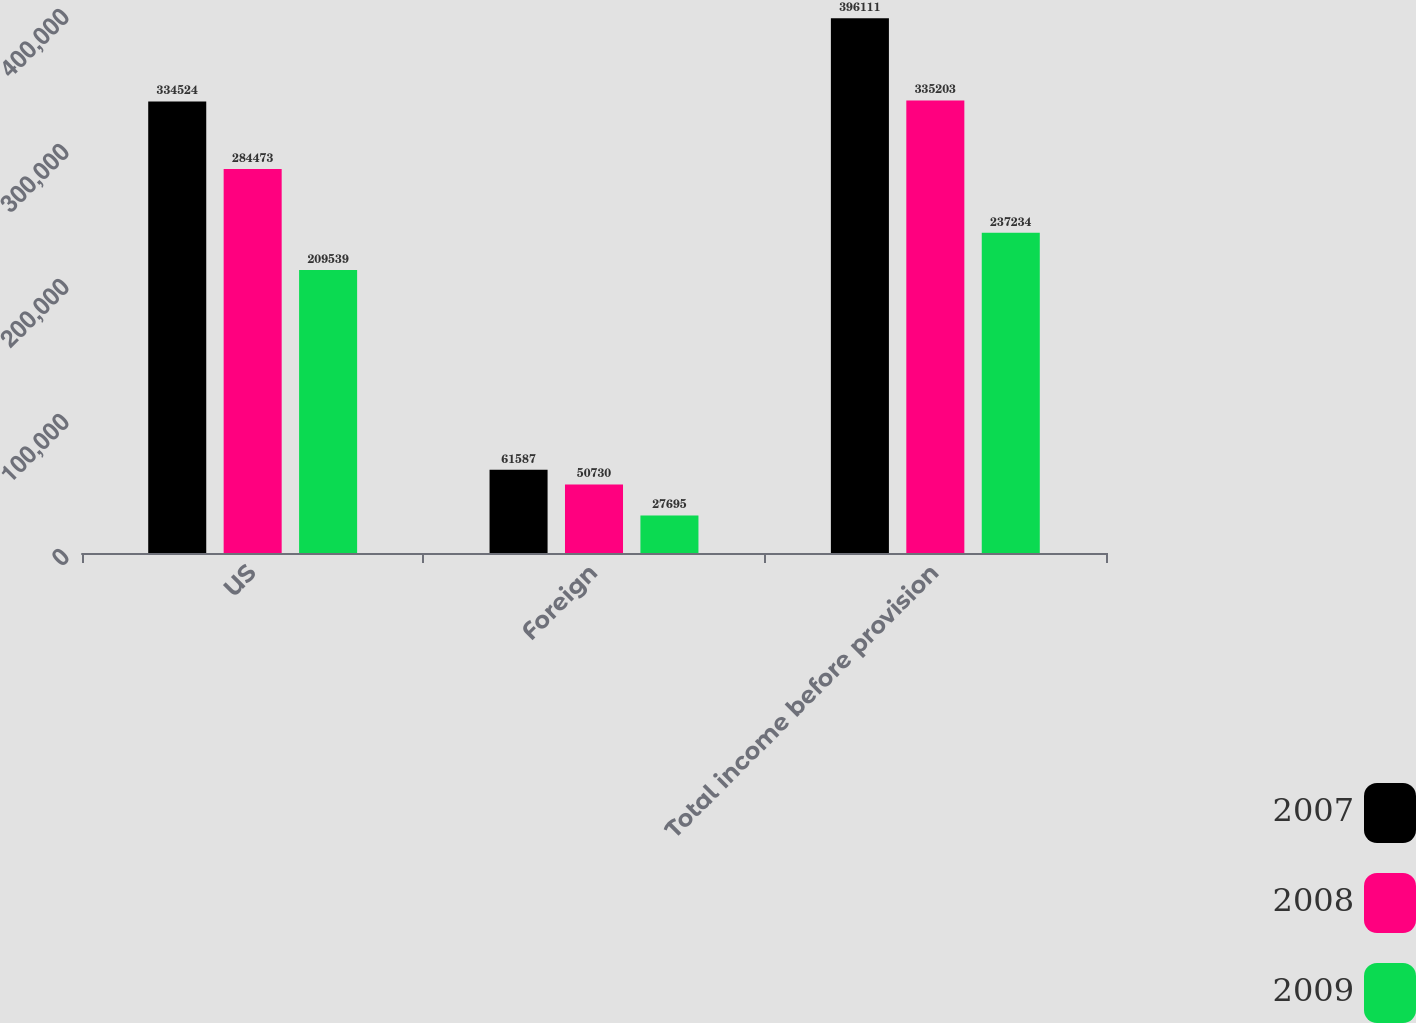Convert chart. <chart><loc_0><loc_0><loc_500><loc_500><stacked_bar_chart><ecel><fcel>US<fcel>Foreign<fcel>Total income before provision<nl><fcel>2007<fcel>334524<fcel>61587<fcel>396111<nl><fcel>2008<fcel>284473<fcel>50730<fcel>335203<nl><fcel>2009<fcel>209539<fcel>27695<fcel>237234<nl></chart> 